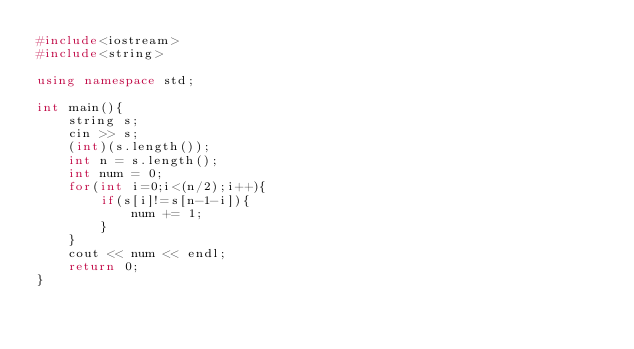<code> <loc_0><loc_0><loc_500><loc_500><_C++_>#include<iostream>
#include<string>

using namespace std;

int main(){
    string s;
    cin >> s;
    (int)(s.length());
    int n = s.length();
    int num = 0;
    for(int i=0;i<(n/2);i++){
        if(s[i]!=s[n-1-i]){
            num += 1;
        }
    }
    cout << num << endl;
    return 0;
}</code> 